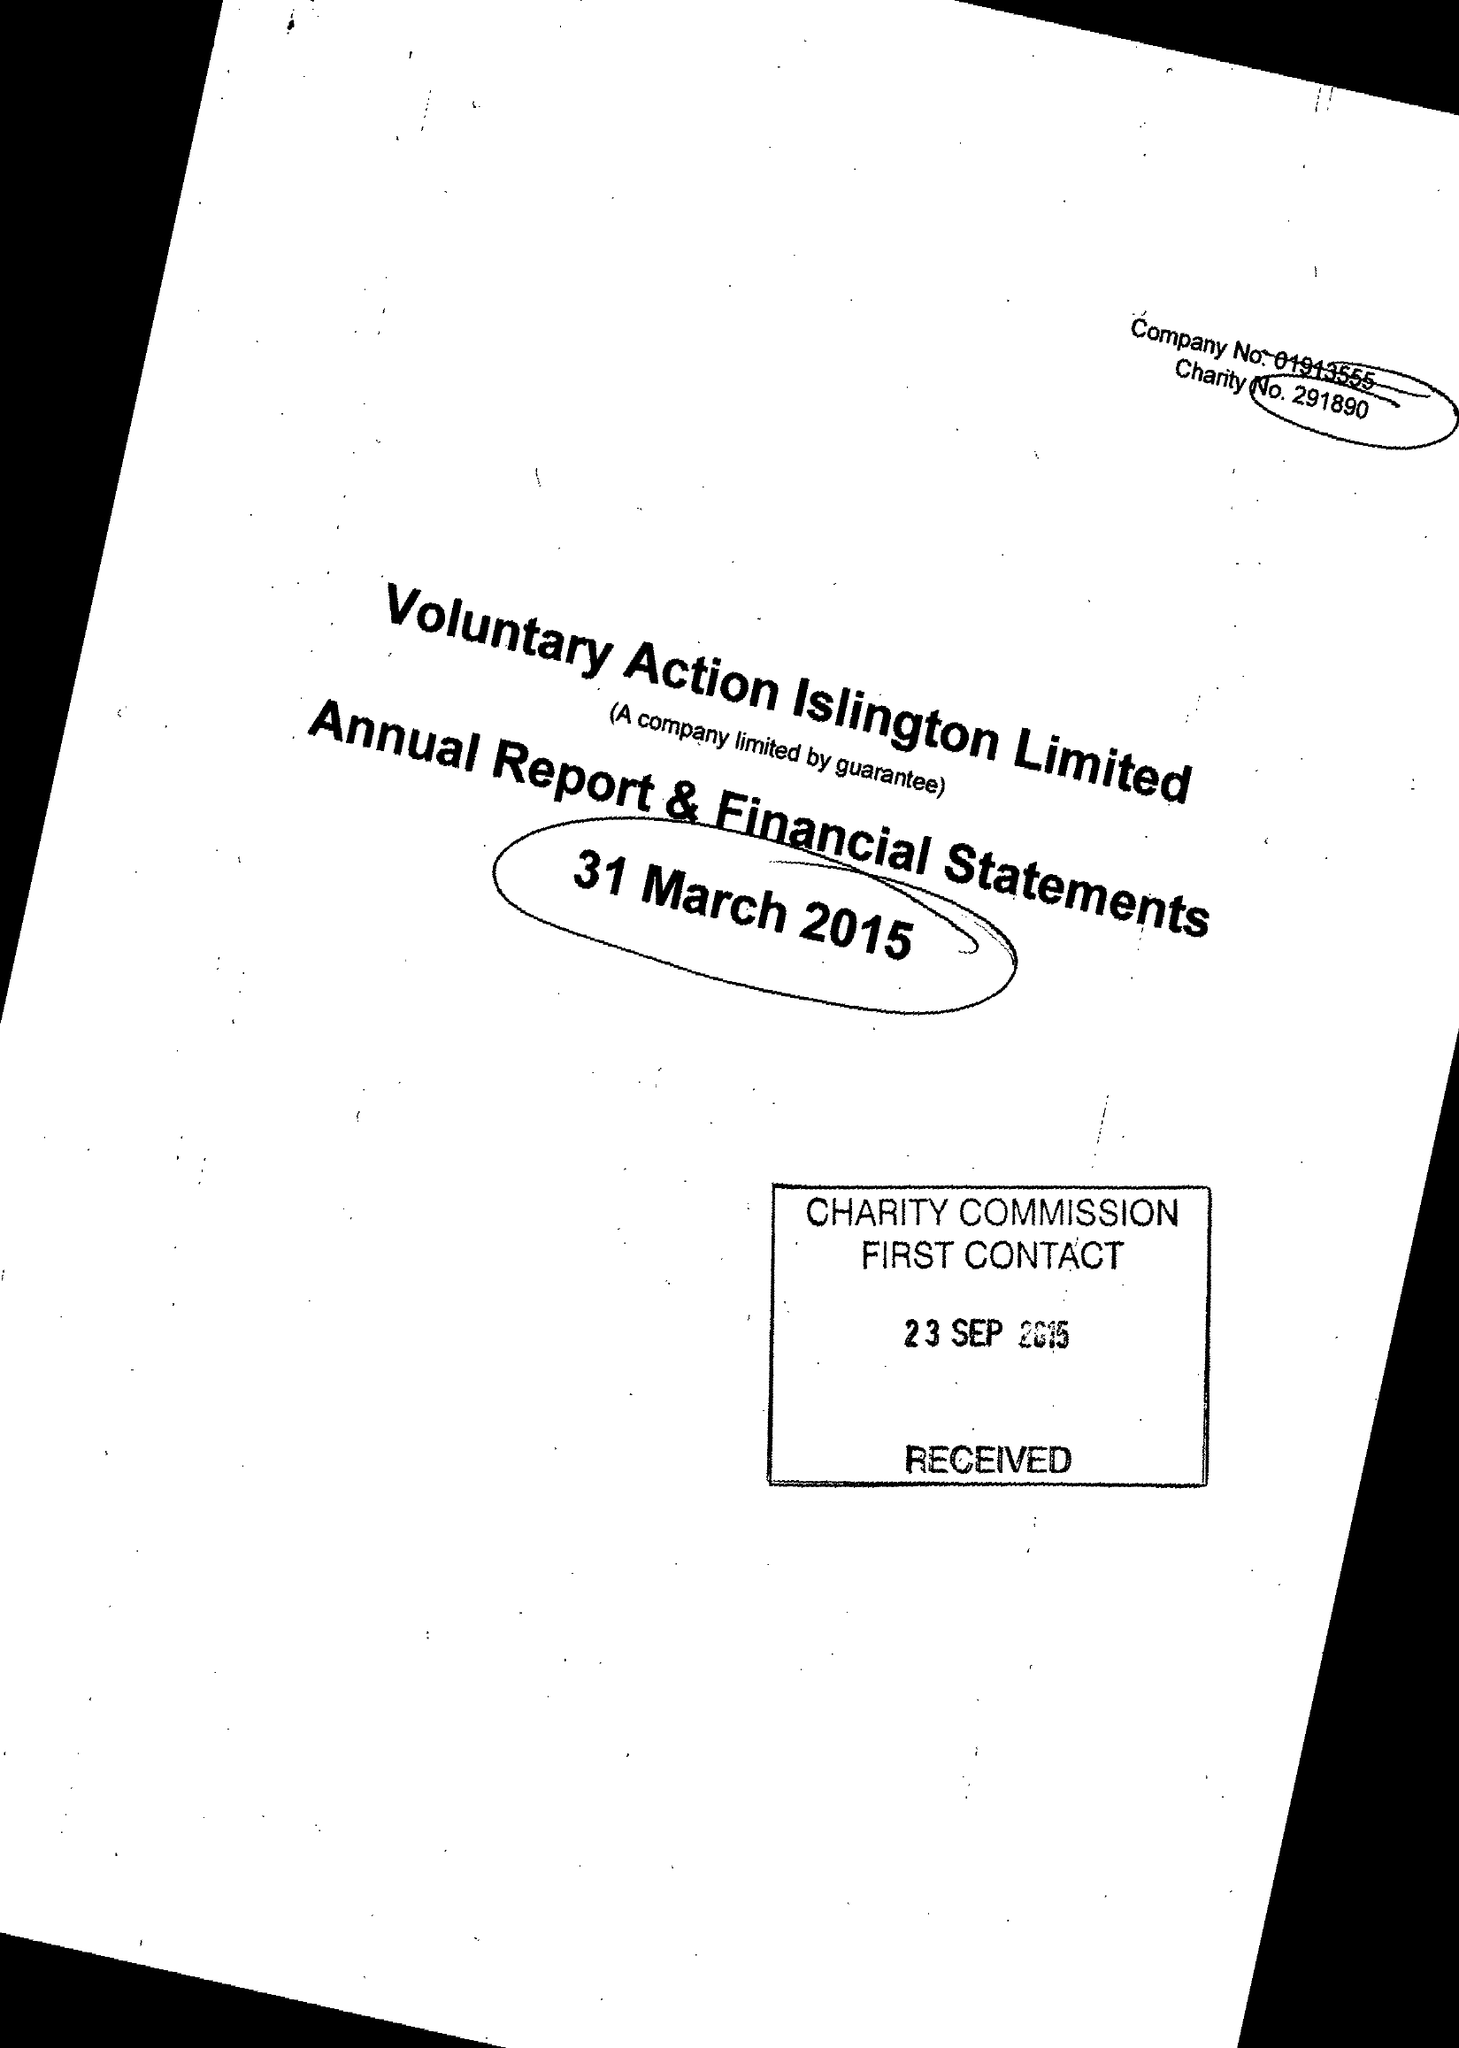What is the value for the address__street_line?
Answer the question using a single word or phrase. 200A PENTONVILLE ROAD 